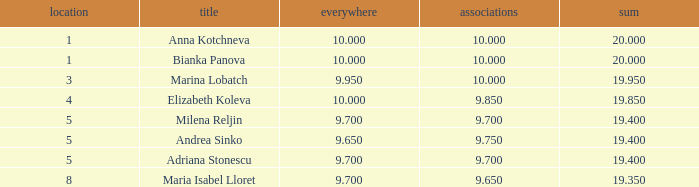What is the highest total that has andrea sinko as the name, with an all around greater than 9.65? None. 